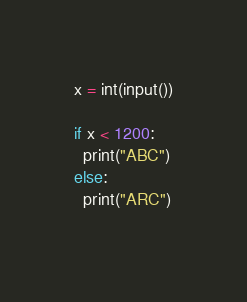<code> <loc_0><loc_0><loc_500><loc_500><_Python_>x = int(input())

if x < 1200:
  print("ABC")
else:
  print("ARC")
  </code> 